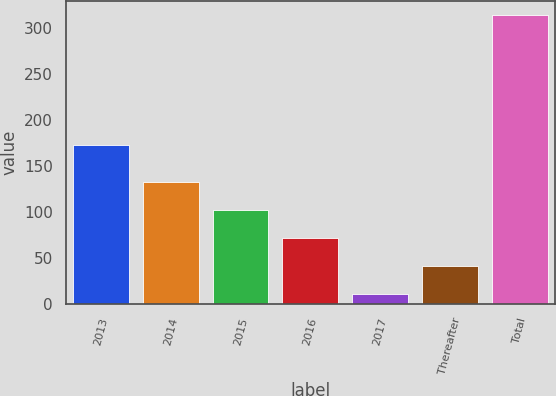Convert chart to OTSL. <chart><loc_0><loc_0><loc_500><loc_500><bar_chart><fcel>2013<fcel>2014<fcel>2015<fcel>2016<fcel>2017<fcel>Thereafter<fcel>Total<nl><fcel>172.8<fcel>132<fcel>101.7<fcel>71.4<fcel>10.8<fcel>41.1<fcel>313.8<nl></chart> 